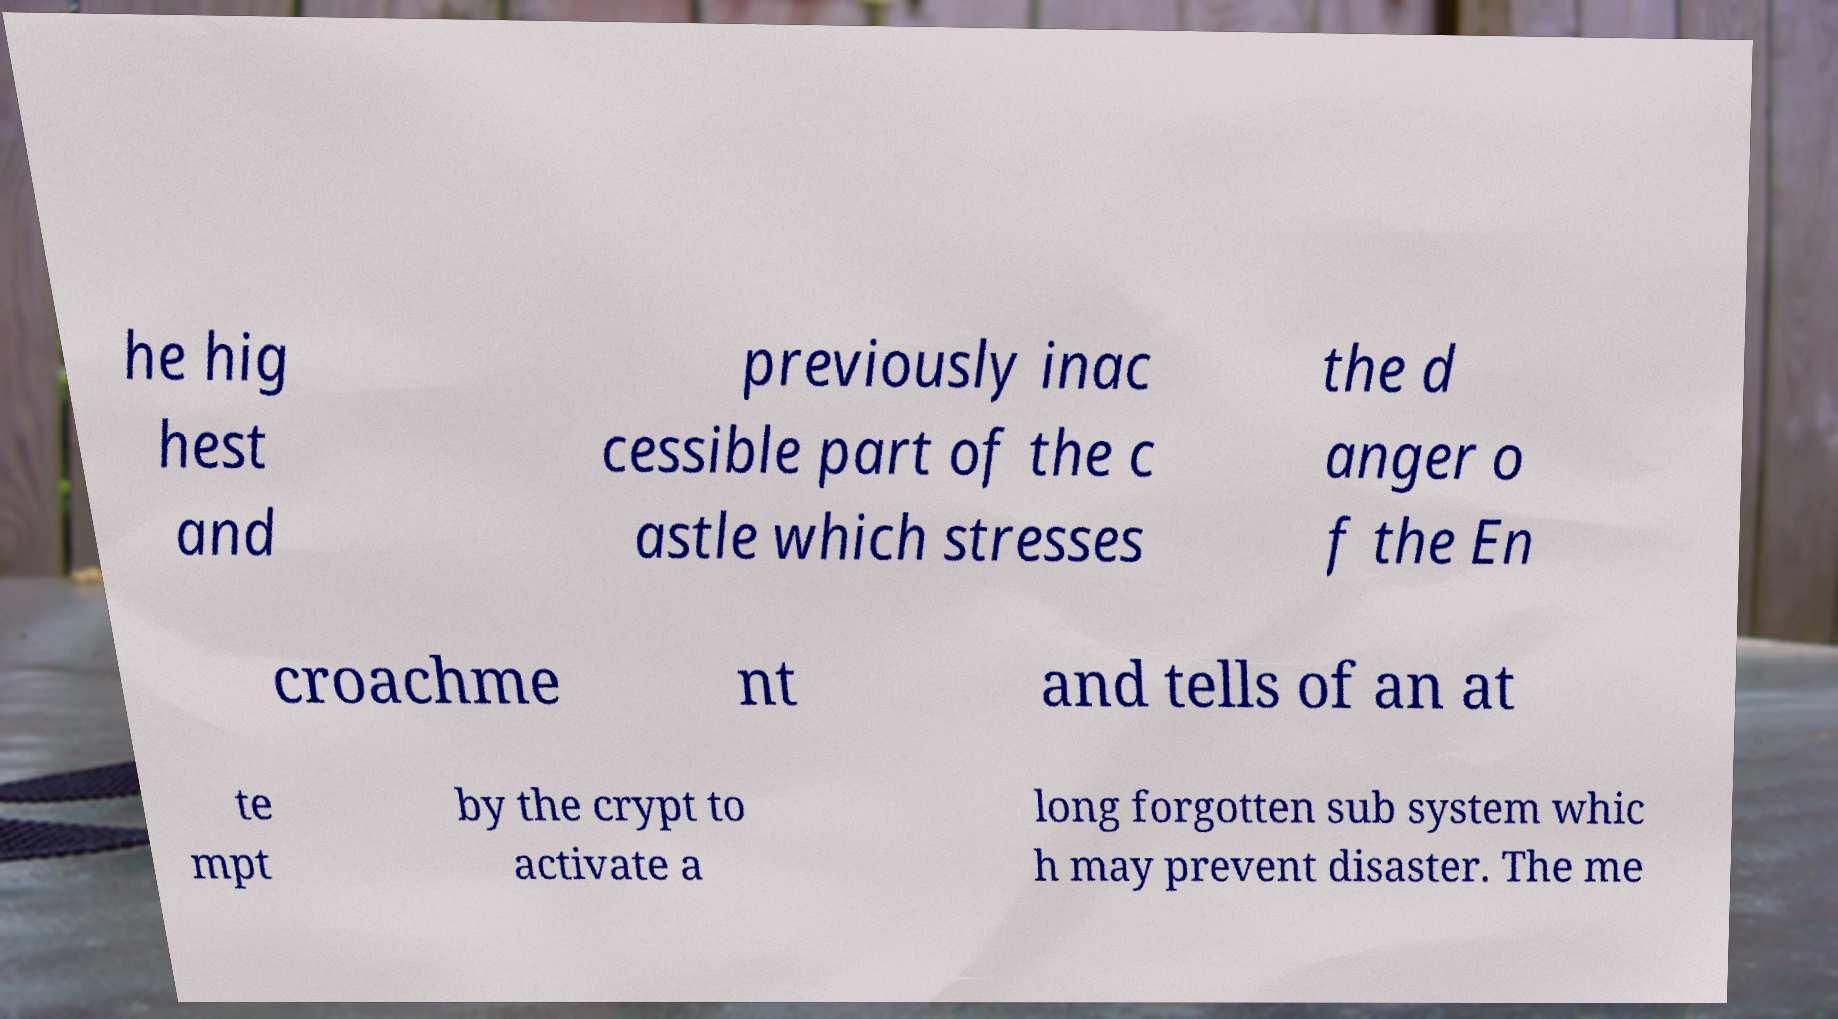I need the written content from this picture converted into text. Can you do that? he hig hest and previously inac cessible part of the c astle which stresses the d anger o f the En croachme nt and tells of an at te mpt by the crypt to activate a long forgotten sub system whic h may prevent disaster. The me 